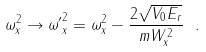<formula> <loc_0><loc_0><loc_500><loc_500>\omega _ { x } ^ { 2 } \rightarrow { \omega ^ { \prime } } _ { x } ^ { 2 } = \omega _ { x } ^ { 2 } - \frac { 2 \sqrt { V _ { 0 } E _ { r } } } { m W _ { x } ^ { 2 } } \ .</formula> 